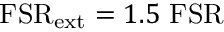<formula> <loc_0><loc_0><loc_500><loc_500>F S R _ { e x t } = 1 . 5 F S R</formula> 